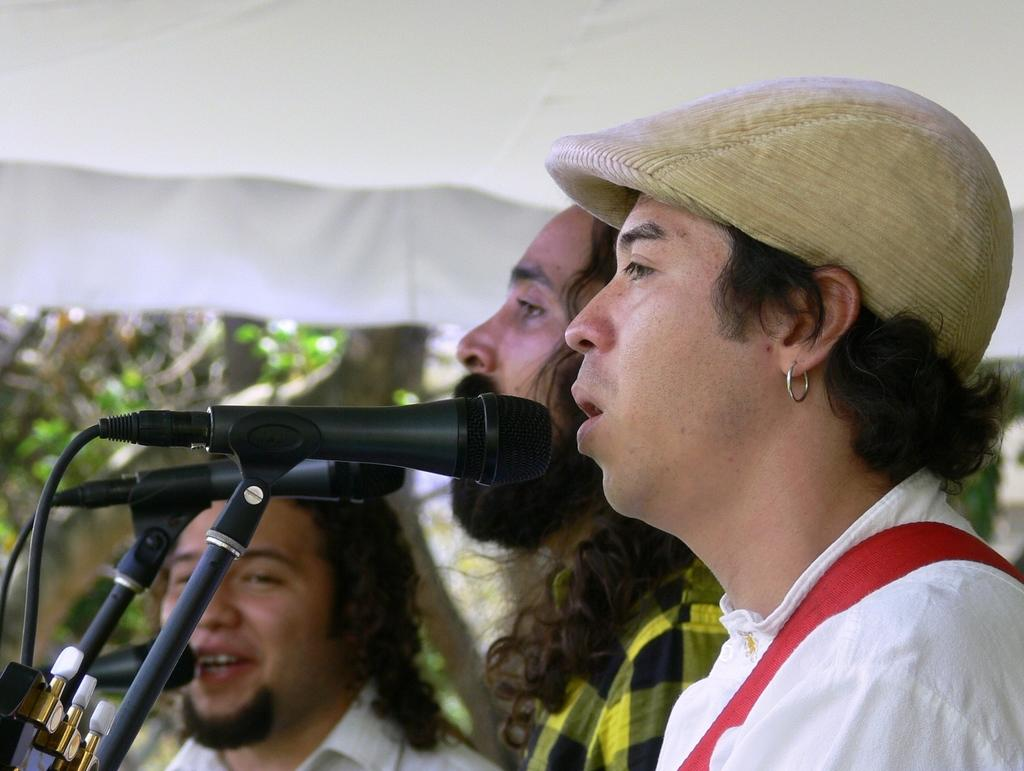How many people are in the image? There are three persons in the image. What are the people doing in the image? The three persons are standing in front of a microphone and singing. Can you describe the attire of one of the persons? One person is wearing a hat. What can be seen in the background of the image? There are trees visible in the image. What is used to hold the microphone in the image? There is a microphone holder in the image. What type of punishment is being administered to the robin in the image? There is no robin present in the image, and therefore no punishment can be observed. What material is the rod used for the punishment made of in the image? There is no rod or punishment present in the image. 